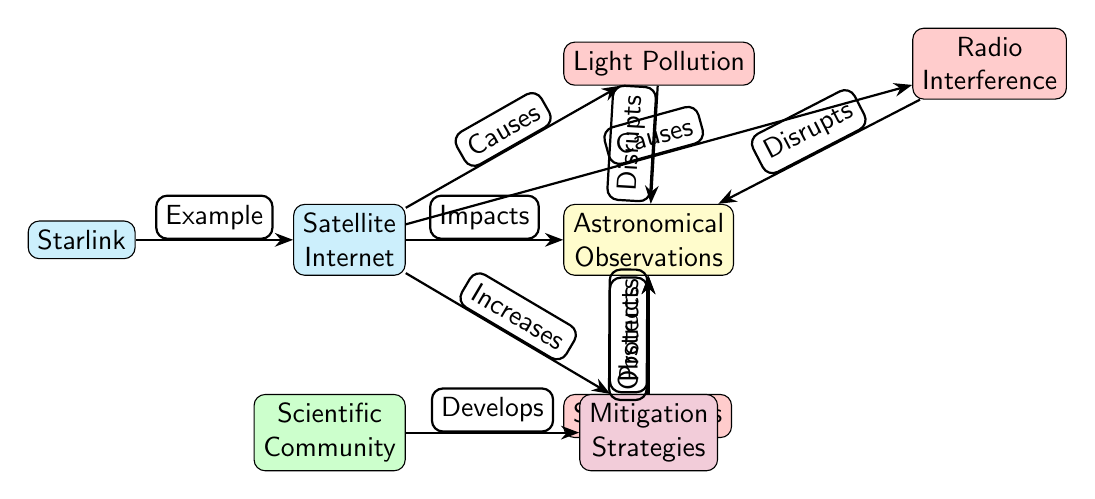What is the main subject of the diagram? The central theme of the diagram is the relationship between Satellite Internet and Astronomical Observations. The node labeled "Satellite Internet" connects directly to "Astronomical Observations," indicating that it's the primary focus of the diagram.
Answer: Satellite Internet How many nodes are present in the diagram? By counting all the distinct labeled shapes in the diagram, we find there are eight nodes: Satellite Internet, Astronomical Observations, Light Pollution, Radio Interference, Starlink, Space Debris, Scientific Community, and Mitigation Strategies.
Answer: 8 What type of impact does Light Pollution have? The diagram shows an edge leading from Light Pollution to Astronomical Observations, labeled "Disrupts." This indicates that Light Pollution negatively affects or interferes with Astronomical Observations.
Answer: Disrupts What causes Radio Interference? The diagram indicates that Satellite Internet causes Radio Interference, as shown by the edge connecting Satellite Internet to Radio Interference with the label "Causes."
Answer: Causes Which node represents a specific example of Satellite Internet? The node labeled "Starlink" is connected to the "Satellite Internet" node and marked with the label "Example," indicating that it serves as a specific instance of Satellite Internet in the diagram.
Answer: Starlink What is the relationship between Space Debris and Astronomical Observations? The diagram has an edge from Space Debris to Astronomical Observations marked "Obstructs," signifying that Space Debris creates obstacles or hinders the process of Astronomical Observations.
Answer: Obstructs What does the Scientific Community develop? The diagram illustrates that the Scientific Community develops Mitigation Strategies, as shown by the edge labeled "Develops" connecting the two nodes.
Answer: Mitigation Strategies How does Mitigation Strategies relate to Astronomical Observations? The edge connecting Mitigation Strategies to Astronomical Observations is labeled "Protects," which indicates that these strategies are intended to safeguard or enhance Astronomical Observations from adverse impacts.
Answer: Protects What color represents the nodes related to impacts? The nodes related to impacts in the diagram are filled with red, as seen with the Light Pollution, Radio Interference, and Space Debris nodes—all categorized as "impact" nodes in the design.
Answer: Red How does Starlink relate to Satellite Internet? Starlink is directly connected to the Satellite Internet node through an edge labeled "Example," which signifies that Starlink is a specific type or instance of Satellite Internet presented in the diagram.
Answer: Example 